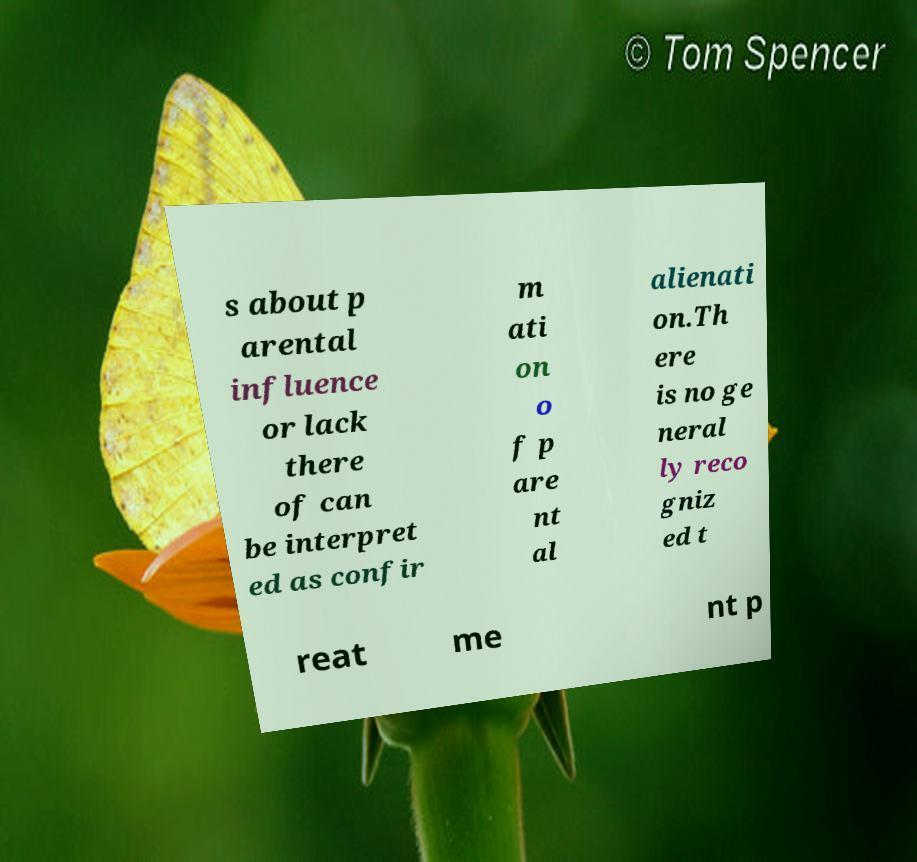Please read and relay the text visible in this image. What does it say? s about p arental influence or lack there of can be interpret ed as confir m ati on o f p are nt al alienati on.Th ere is no ge neral ly reco gniz ed t reat me nt p 